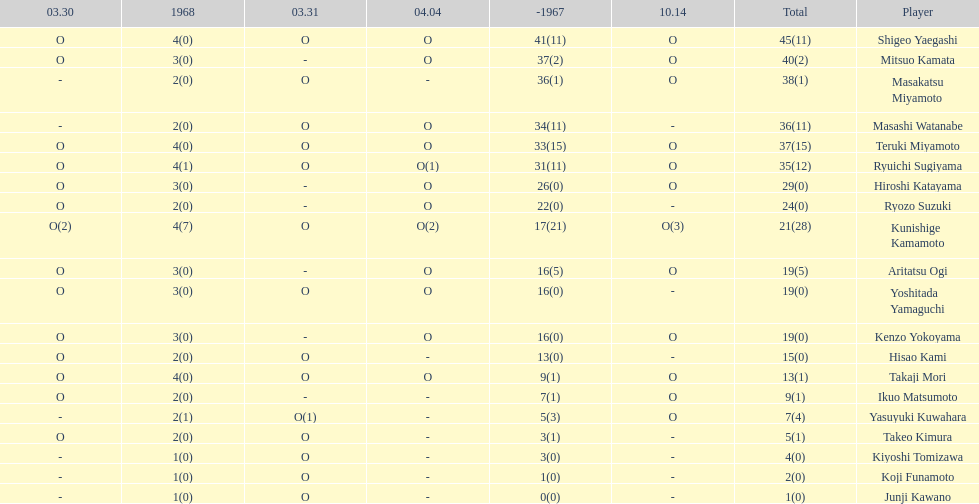How many points did takaji mori have? 13(1). And how many points did junji kawano have? 1(0). To who does the higher of these belong to? Takaji Mori. 